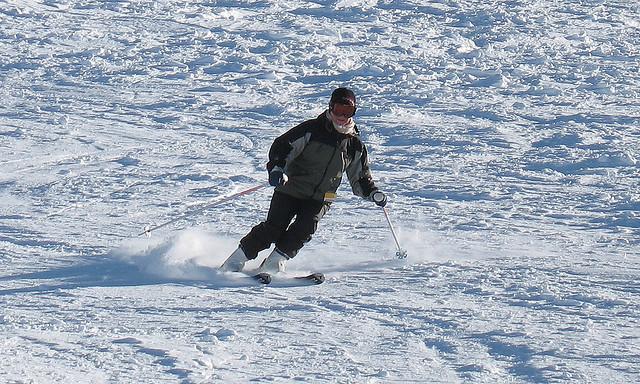How many cars can be seen?
Give a very brief answer. 0. 